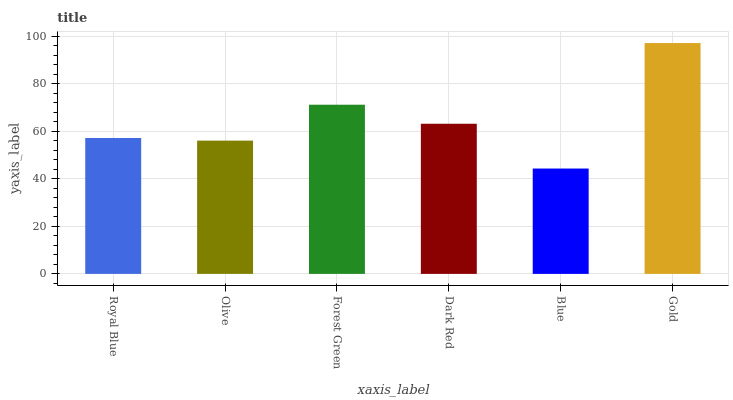Is Blue the minimum?
Answer yes or no. Yes. Is Gold the maximum?
Answer yes or no. Yes. Is Olive the minimum?
Answer yes or no. No. Is Olive the maximum?
Answer yes or no. No. Is Royal Blue greater than Olive?
Answer yes or no. Yes. Is Olive less than Royal Blue?
Answer yes or no. Yes. Is Olive greater than Royal Blue?
Answer yes or no. No. Is Royal Blue less than Olive?
Answer yes or no. No. Is Dark Red the high median?
Answer yes or no. Yes. Is Royal Blue the low median?
Answer yes or no. Yes. Is Forest Green the high median?
Answer yes or no. No. Is Dark Red the low median?
Answer yes or no. No. 